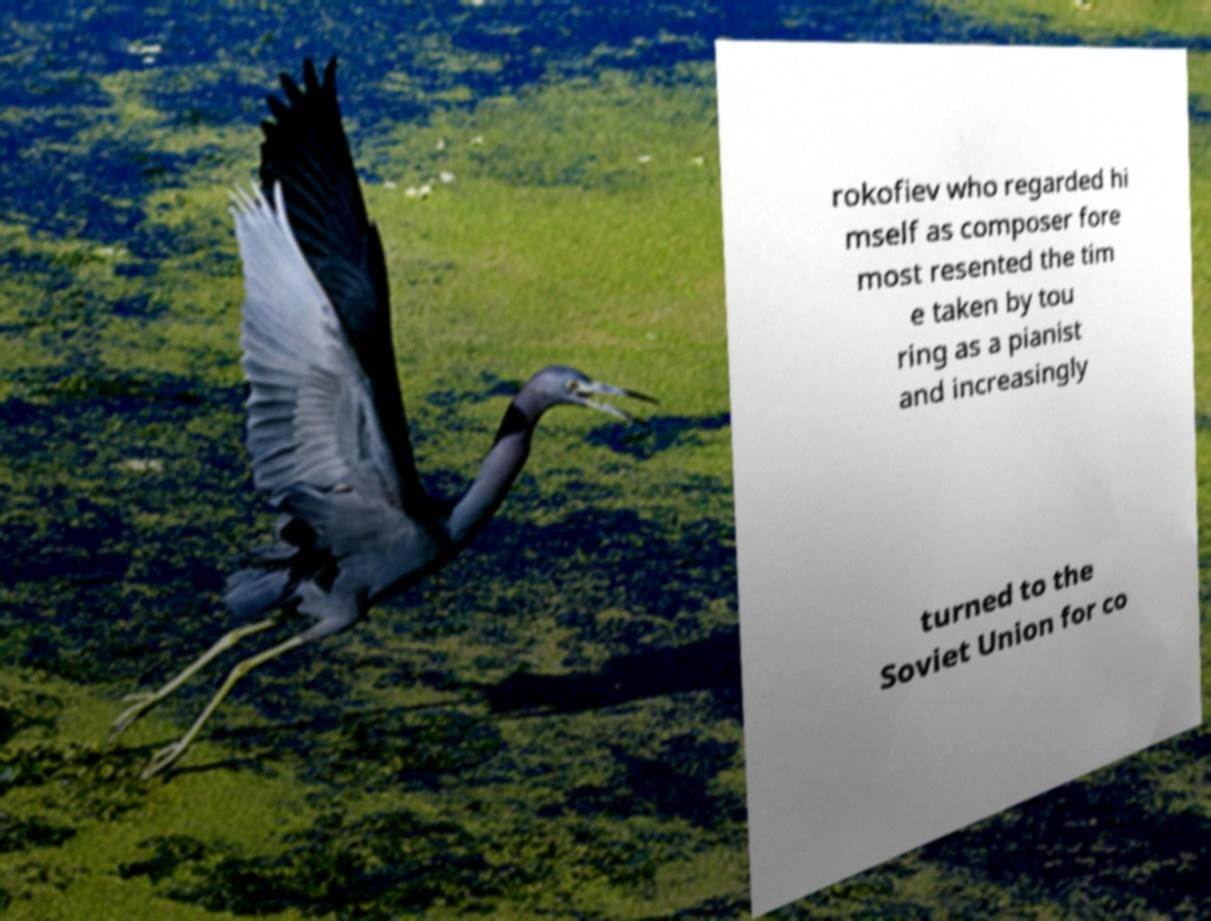Can you read and provide the text displayed in the image?This photo seems to have some interesting text. Can you extract and type it out for me? rokofiev who regarded hi mself as composer fore most resented the tim e taken by tou ring as a pianist and increasingly turned to the Soviet Union for co 